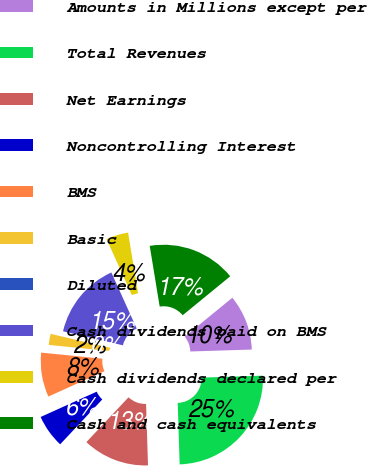<chart> <loc_0><loc_0><loc_500><loc_500><pie_chart><fcel>Amounts in Millions except per<fcel>Total Revenues<fcel>Net Earnings<fcel>Noncontrolling Interest<fcel>BMS<fcel>Basic<fcel>Diluted<fcel>Cash dividends paid on BMS<fcel>Cash dividends declared per<fcel>Cash and cash equivalents<nl><fcel>10.42%<fcel>25.0%<fcel>12.5%<fcel>6.25%<fcel>8.33%<fcel>2.08%<fcel>0.0%<fcel>14.58%<fcel>4.17%<fcel>16.67%<nl></chart> 